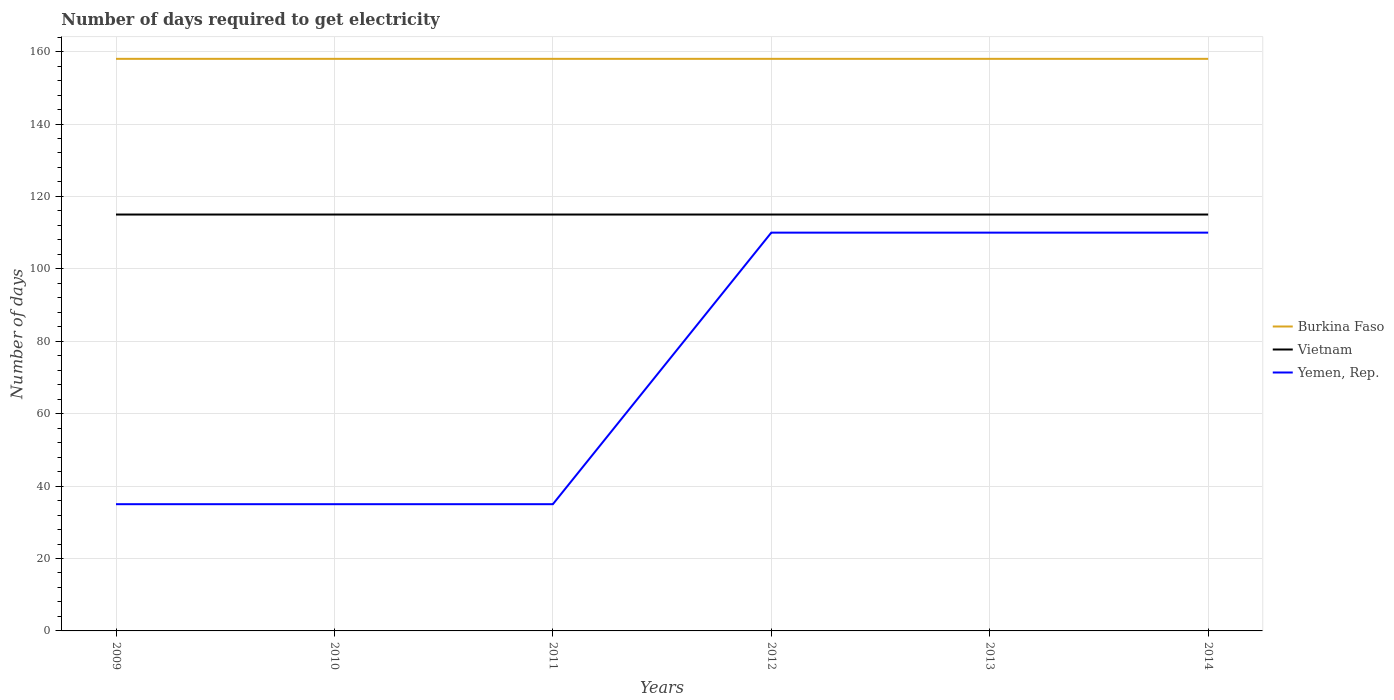Across all years, what is the maximum number of days required to get electricity in in Burkina Faso?
Keep it short and to the point. 158. What is the total number of days required to get electricity in in Burkina Faso in the graph?
Your answer should be very brief. 0. Is the number of days required to get electricity in in Vietnam strictly greater than the number of days required to get electricity in in Burkina Faso over the years?
Provide a succinct answer. Yes. How many lines are there?
Provide a short and direct response. 3. Are the values on the major ticks of Y-axis written in scientific E-notation?
Give a very brief answer. No. Does the graph contain any zero values?
Provide a short and direct response. No. Does the graph contain grids?
Ensure brevity in your answer.  Yes. Where does the legend appear in the graph?
Your answer should be very brief. Center right. How many legend labels are there?
Ensure brevity in your answer.  3. What is the title of the graph?
Offer a terse response. Number of days required to get electricity. What is the label or title of the Y-axis?
Your answer should be compact. Number of days. What is the Number of days in Burkina Faso in 2009?
Your answer should be compact. 158. What is the Number of days in Vietnam in 2009?
Your response must be concise. 115. What is the Number of days of Burkina Faso in 2010?
Provide a succinct answer. 158. What is the Number of days in Vietnam in 2010?
Your answer should be compact. 115. What is the Number of days in Burkina Faso in 2011?
Ensure brevity in your answer.  158. What is the Number of days in Vietnam in 2011?
Provide a short and direct response. 115. What is the Number of days in Burkina Faso in 2012?
Ensure brevity in your answer.  158. What is the Number of days of Vietnam in 2012?
Keep it short and to the point. 115. What is the Number of days of Yemen, Rep. in 2012?
Your response must be concise. 110. What is the Number of days of Burkina Faso in 2013?
Your response must be concise. 158. What is the Number of days in Vietnam in 2013?
Give a very brief answer. 115. What is the Number of days in Yemen, Rep. in 2013?
Ensure brevity in your answer.  110. What is the Number of days of Burkina Faso in 2014?
Ensure brevity in your answer.  158. What is the Number of days of Vietnam in 2014?
Give a very brief answer. 115. What is the Number of days in Yemen, Rep. in 2014?
Make the answer very short. 110. Across all years, what is the maximum Number of days of Burkina Faso?
Ensure brevity in your answer.  158. Across all years, what is the maximum Number of days in Vietnam?
Your answer should be very brief. 115. Across all years, what is the maximum Number of days of Yemen, Rep.?
Your response must be concise. 110. Across all years, what is the minimum Number of days in Burkina Faso?
Keep it short and to the point. 158. Across all years, what is the minimum Number of days in Vietnam?
Give a very brief answer. 115. What is the total Number of days of Burkina Faso in the graph?
Offer a very short reply. 948. What is the total Number of days in Vietnam in the graph?
Ensure brevity in your answer.  690. What is the total Number of days in Yemen, Rep. in the graph?
Your answer should be compact. 435. What is the difference between the Number of days of Burkina Faso in 2009 and that in 2010?
Make the answer very short. 0. What is the difference between the Number of days in Vietnam in 2009 and that in 2010?
Make the answer very short. 0. What is the difference between the Number of days in Vietnam in 2009 and that in 2011?
Your response must be concise. 0. What is the difference between the Number of days in Yemen, Rep. in 2009 and that in 2011?
Provide a short and direct response. 0. What is the difference between the Number of days in Yemen, Rep. in 2009 and that in 2012?
Provide a short and direct response. -75. What is the difference between the Number of days of Vietnam in 2009 and that in 2013?
Your answer should be very brief. 0. What is the difference between the Number of days in Yemen, Rep. in 2009 and that in 2013?
Ensure brevity in your answer.  -75. What is the difference between the Number of days in Yemen, Rep. in 2009 and that in 2014?
Provide a succinct answer. -75. What is the difference between the Number of days in Burkina Faso in 2010 and that in 2012?
Your answer should be compact. 0. What is the difference between the Number of days of Yemen, Rep. in 2010 and that in 2012?
Your response must be concise. -75. What is the difference between the Number of days of Burkina Faso in 2010 and that in 2013?
Your answer should be compact. 0. What is the difference between the Number of days in Vietnam in 2010 and that in 2013?
Your response must be concise. 0. What is the difference between the Number of days in Yemen, Rep. in 2010 and that in 2013?
Offer a very short reply. -75. What is the difference between the Number of days of Yemen, Rep. in 2010 and that in 2014?
Ensure brevity in your answer.  -75. What is the difference between the Number of days of Burkina Faso in 2011 and that in 2012?
Offer a terse response. 0. What is the difference between the Number of days of Yemen, Rep. in 2011 and that in 2012?
Offer a terse response. -75. What is the difference between the Number of days in Burkina Faso in 2011 and that in 2013?
Your response must be concise. 0. What is the difference between the Number of days in Vietnam in 2011 and that in 2013?
Provide a short and direct response. 0. What is the difference between the Number of days of Yemen, Rep. in 2011 and that in 2013?
Make the answer very short. -75. What is the difference between the Number of days of Vietnam in 2011 and that in 2014?
Offer a very short reply. 0. What is the difference between the Number of days of Yemen, Rep. in 2011 and that in 2014?
Make the answer very short. -75. What is the difference between the Number of days in Vietnam in 2012 and that in 2013?
Give a very brief answer. 0. What is the difference between the Number of days in Yemen, Rep. in 2012 and that in 2013?
Give a very brief answer. 0. What is the difference between the Number of days of Vietnam in 2012 and that in 2014?
Ensure brevity in your answer.  0. What is the difference between the Number of days in Burkina Faso in 2013 and that in 2014?
Offer a very short reply. 0. What is the difference between the Number of days of Yemen, Rep. in 2013 and that in 2014?
Offer a very short reply. 0. What is the difference between the Number of days of Burkina Faso in 2009 and the Number of days of Vietnam in 2010?
Offer a very short reply. 43. What is the difference between the Number of days in Burkina Faso in 2009 and the Number of days in Yemen, Rep. in 2010?
Your answer should be compact. 123. What is the difference between the Number of days of Vietnam in 2009 and the Number of days of Yemen, Rep. in 2010?
Your answer should be compact. 80. What is the difference between the Number of days in Burkina Faso in 2009 and the Number of days in Yemen, Rep. in 2011?
Provide a succinct answer. 123. What is the difference between the Number of days in Burkina Faso in 2009 and the Number of days in Yemen, Rep. in 2013?
Offer a very short reply. 48. What is the difference between the Number of days of Burkina Faso in 2009 and the Number of days of Yemen, Rep. in 2014?
Give a very brief answer. 48. What is the difference between the Number of days in Burkina Faso in 2010 and the Number of days in Yemen, Rep. in 2011?
Your response must be concise. 123. What is the difference between the Number of days of Vietnam in 2010 and the Number of days of Yemen, Rep. in 2011?
Provide a short and direct response. 80. What is the difference between the Number of days of Burkina Faso in 2010 and the Number of days of Vietnam in 2012?
Provide a succinct answer. 43. What is the difference between the Number of days in Burkina Faso in 2010 and the Number of days in Yemen, Rep. in 2013?
Offer a very short reply. 48. What is the difference between the Number of days of Vietnam in 2010 and the Number of days of Yemen, Rep. in 2013?
Your answer should be very brief. 5. What is the difference between the Number of days of Burkina Faso in 2010 and the Number of days of Yemen, Rep. in 2014?
Your response must be concise. 48. What is the difference between the Number of days in Vietnam in 2010 and the Number of days in Yemen, Rep. in 2014?
Offer a terse response. 5. What is the difference between the Number of days in Burkina Faso in 2011 and the Number of days in Vietnam in 2012?
Provide a succinct answer. 43. What is the difference between the Number of days of Burkina Faso in 2011 and the Number of days of Yemen, Rep. in 2012?
Offer a very short reply. 48. What is the difference between the Number of days of Burkina Faso in 2011 and the Number of days of Yemen, Rep. in 2013?
Ensure brevity in your answer.  48. What is the difference between the Number of days in Burkina Faso in 2011 and the Number of days in Vietnam in 2014?
Keep it short and to the point. 43. What is the difference between the Number of days in Vietnam in 2012 and the Number of days in Yemen, Rep. in 2013?
Offer a terse response. 5. What is the difference between the Number of days of Burkina Faso in 2012 and the Number of days of Vietnam in 2014?
Keep it short and to the point. 43. What is the difference between the Number of days of Burkina Faso in 2012 and the Number of days of Yemen, Rep. in 2014?
Provide a succinct answer. 48. What is the difference between the Number of days in Burkina Faso in 2013 and the Number of days in Vietnam in 2014?
Keep it short and to the point. 43. What is the difference between the Number of days of Vietnam in 2013 and the Number of days of Yemen, Rep. in 2014?
Keep it short and to the point. 5. What is the average Number of days of Burkina Faso per year?
Ensure brevity in your answer.  158. What is the average Number of days in Vietnam per year?
Provide a short and direct response. 115. What is the average Number of days in Yemen, Rep. per year?
Provide a succinct answer. 72.5. In the year 2009, what is the difference between the Number of days of Burkina Faso and Number of days of Vietnam?
Ensure brevity in your answer.  43. In the year 2009, what is the difference between the Number of days of Burkina Faso and Number of days of Yemen, Rep.?
Your answer should be very brief. 123. In the year 2010, what is the difference between the Number of days in Burkina Faso and Number of days in Vietnam?
Your answer should be compact. 43. In the year 2010, what is the difference between the Number of days of Burkina Faso and Number of days of Yemen, Rep.?
Give a very brief answer. 123. In the year 2010, what is the difference between the Number of days of Vietnam and Number of days of Yemen, Rep.?
Provide a short and direct response. 80. In the year 2011, what is the difference between the Number of days in Burkina Faso and Number of days in Vietnam?
Provide a succinct answer. 43. In the year 2011, what is the difference between the Number of days in Burkina Faso and Number of days in Yemen, Rep.?
Offer a very short reply. 123. In the year 2012, what is the difference between the Number of days in Burkina Faso and Number of days in Vietnam?
Your answer should be very brief. 43. In the year 2013, what is the difference between the Number of days in Burkina Faso and Number of days in Vietnam?
Provide a short and direct response. 43. In the year 2014, what is the difference between the Number of days in Vietnam and Number of days in Yemen, Rep.?
Your response must be concise. 5. What is the ratio of the Number of days in Yemen, Rep. in 2009 to that in 2012?
Your answer should be very brief. 0.32. What is the ratio of the Number of days in Yemen, Rep. in 2009 to that in 2013?
Your answer should be very brief. 0.32. What is the ratio of the Number of days in Yemen, Rep. in 2009 to that in 2014?
Make the answer very short. 0.32. What is the ratio of the Number of days of Burkina Faso in 2010 to that in 2011?
Give a very brief answer. 1. What is the ratio of the Number of days in Yemen, Rep. in 2010 to that in 2012?
Your answer should be compact. 0.32. What is the ratio of the Number of days in Burkina Faso in 2010 to that in 2013?
Keep it short and to the point. 1. What is the ratio of the Number of days of Vietnam in 2010 to that in 2013?
Give a very brief answer. 1. What is the ratio of the Number of days in Yemen, Rep. in 2010 to that in 2013?
Your answer should be compact. 0.32. What is the ratio of the Number of days of Burkina Faso in 2010 to that in 2014?
Your answer should be compact. 1. What is the ratio of the Number of days in Vietnam in 2010 to that in 2014?
Offer a very short reply. 1. What is the ratio of the Number of days in Yemen, Rep. in 2010 to that in 2014?
Provide a succinct answer. 0.32. What is the ratio of the Number of days in Burkina Faso in 2011 to that in 2012?
Give a very brief answer. 1. What is the ratio of the Number of days of Vietnam in 2011 to that in 2012?
Offer a terse response. 1. What is the ratio of the Number of days in Yemen, Rep. in 2011 to that in 2012?
Give a very brief answer. 0.32. What is the ratio of the Number of days of Vietnam in 2011 to that in 2013?
Offer a terse response. 1. What is the ratio of the Number of days in Yemen, Rep. in 2011 to that in 2013?
Your answer should be very brief. 0.32. What is the ratio of the Number of days of Vietnam in 2011 to that in 2014?
Make the answer very short. 1. What is the ratio of the Number of days of Yemen, Rep. in 2011 to that in 2014?
Your response must be concise. 0.32. What is the ratio of the Number of days of Burkina Faso in 2013 to that in 2014?
Give a very brief answer. 1. What is the difference between the highest and the second highest Number of days in Burkina Faso?
Offer a terse response. 0. What is the difference between the highest and the second highest Number of days of Vietnam?
Your answer should be very brief. 0. What is the difference between the highest and the lowest Number of days in Burkina Faso?
Offer a terse response. 0. What is the difference between the highest and the lowest Number of days of Vietnam?
Offer a terse response. 0. 